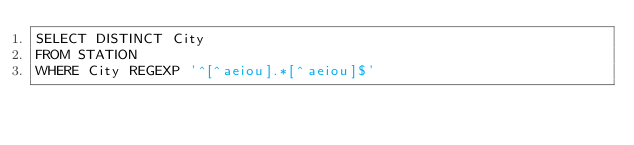<code> <loc_0><loc_0><loc_500><loc_500><_SQL_>SELECT DISTINCT City
FROM STATION
WHERE City REGEXP '^[^aeiou].*[^aeiou]$'</code> 